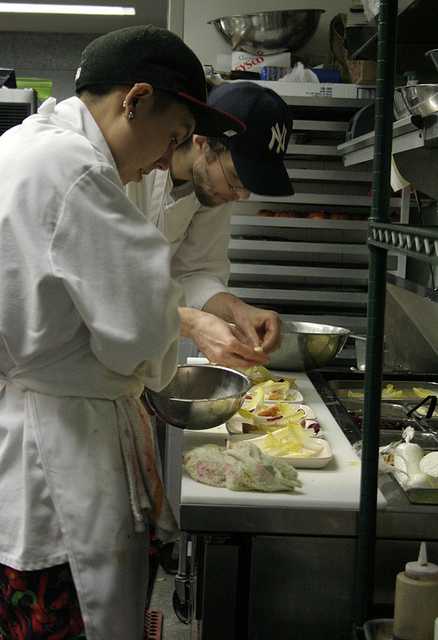<image>What cuisine is being prepared? I don't know what cuisine is being prepared as it can be any - from salad, desserts, asian, vegetarian, american to italian, fancy, dessert, or pizza. What fruit is on the table? I am not sure what fruit is on the table. It could be pears, apple, berries, tomato, strawberry or melon. What is in the oven? It is unknown what is in the oven. It could be food, bread, pizza, or nothing. What cuisine is being prepared? I am not sure what cuisine is being prepared. It can be salad, desserts, asian, vegetarian, american, italian, fancy, dessert, or pizza. What fruit is on the table? I am not sure what fruit is on the table. It can be seen pears, apple, berries, tomato, strawberry or melon. What is in the oven? There is food in the oven. 